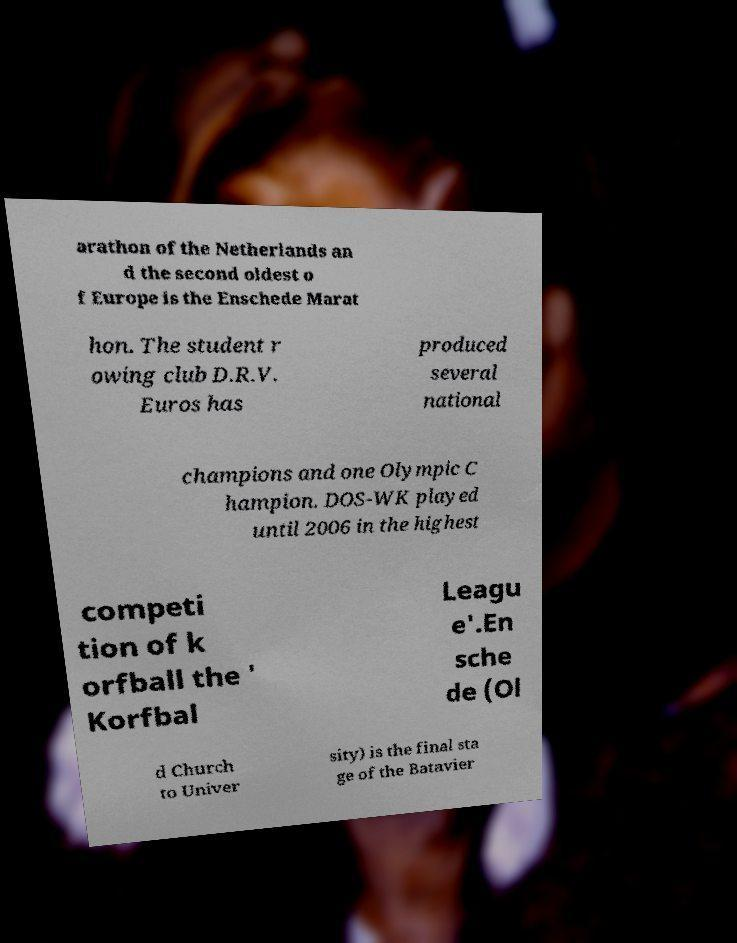There's text embedded in this image that I need extracted. Can you transcribe it verbatim? arathon of the Netherlands an d the second oldest o f Europe is the Enschede Marat hon. The student r owing club D.R.V. Euros has produced several national champions and one Olympic C hampion. DOS-WK played until 2006 in the highest competi tion of k orfball the ' Korfbal Leagu e'.En sche de (Ol d Church to Univer sity) is the final sta ge of the Batavier 